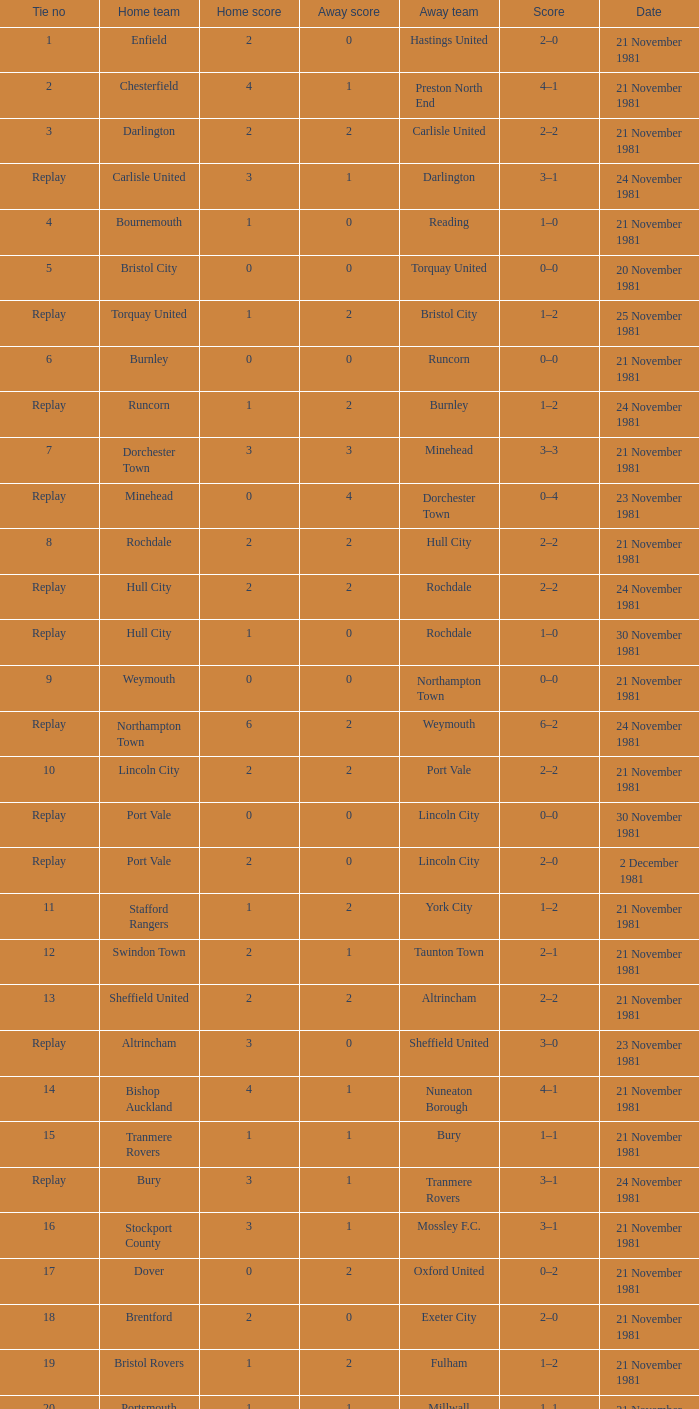What is the tie number for minehead? Replay. 